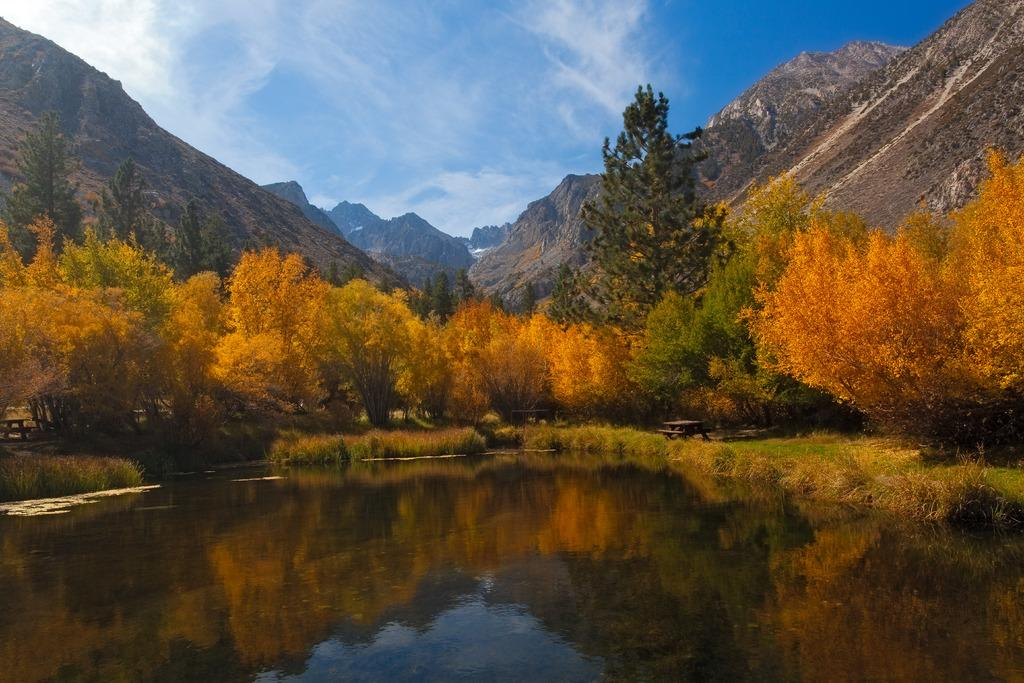What type of vegetation can be seen in the image? There are plants and trees visible in the image. What natural feature can be seen in the image? There is water visible in the image. What type of landscape is depicted in the image? There are hills in the image. What is visible in the background of the image? The sky is visible in the image. What type of design can be seen on the earth in the image? There is no earth present in the image, as it is a landscape with plants, trees, water, hills, and sky. 